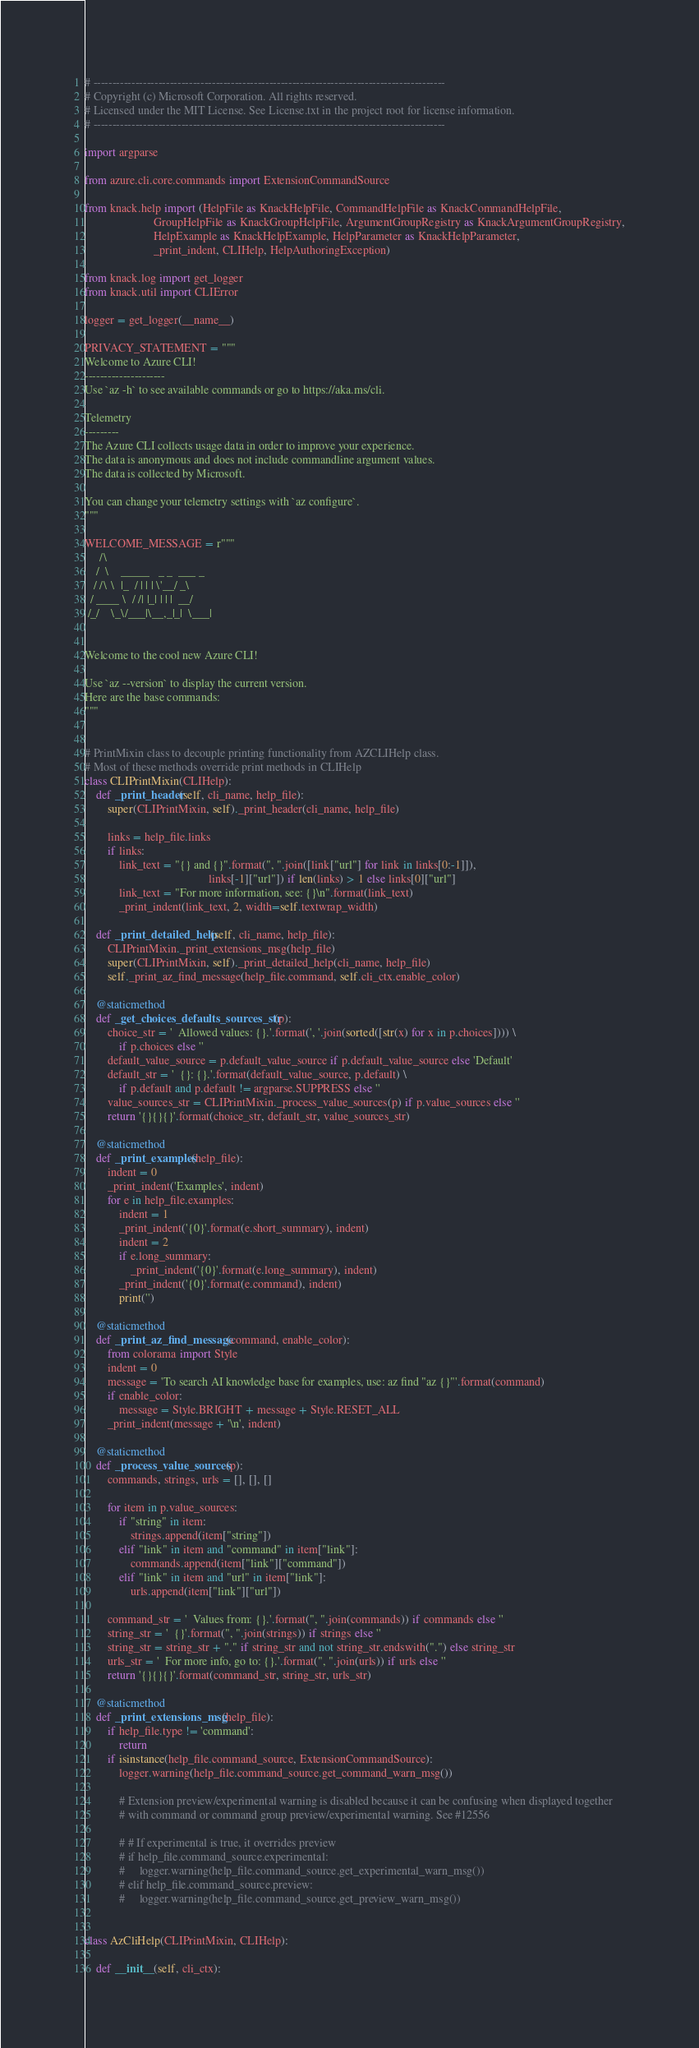<code> <loc_0><loc_0><loc_500><loc_500><_Python_># --------------------------------------------------------------------------------------------
# Copyright (c) Microsoft Corporation. All rights reserved.
# Licensed under the MIT License. See License.txt in the project root for license information.
# --------------------------------------------------------------------------------------------

import argparse

from azure.cli.core.commands import ExtensionCommandSource

from knack.help import (HelpFile as KnackHelpFile, CommandHelpFile as KnackCommandHelpFile,
                        GroupHelpFile as KnackGroupHelpFile, ArgumentGroupRegistry as KnackArgumentGroupRegistry,
                        HelpExample as KnackHelpExample, HelpParameter as KnackHelpParameter,
                        _print_indent, CLIHelp, HelpAuthoringException)

from knack.log import get_logger
from knack.util import CLIError

logger = get_logger(__name__)

PRIVACY_STATEMENT = """
Welcome to Azure CLI!
---------------------
Use `az -h` to see available commands or go to https://aka.ms/cli.

Telemetry
---------
The Azure CLI collects usage data in order to improve your experience.
The data is anonymous and does not include commandline argument values.
The data is collected by Microsoft.

You can change your telemetry settings with `az configure`.
"""

WELCOME_MESSAGE = r"""
     /\
    /  \    _____   _ _  ___ _
   / /\ \  |_  / | | | \'__/ _\
  / ____ \  / /| |_| | | |  __/
 /_/    \_\/___|\__,_|_|  \___|


Welcome to the cool new Azure CLI!

Use `az --version` to display the current version.
Here are the base commands:
"""


# PrintMixin class to decouple printing functionality from AZCLIHelp class.
# Most of these methods override print methods in CLIHelp
class CLIPrintMixin(CLIHelp):
    def _print_header(self, cli_name, help_file):
        super(CLIPrintMixin, self)._print_header(cli_name, help_file)

        links = help_file.links
        if links:
            link_text = "{} and {}".format(", ".join([link["url"] for link in links[0:-1]]),
                                           links[-1]["url"]) if len(links) > 1 else links[0]["url"]
            link_text = "For more information, see: {}\n".format(link_text)
            _print_indent(link_text, 2, width=self.textwrap_width)

    def _print_detailed_help(self, cli_name, help_file):
        CLIPrintMixin._print_extensions_msg(help_file)
        super(CLIPrintMixin, self)._print_detailed_help(cli_name, help_file)
        self._print_az_find_message(help_file.command, self.cli_ctx.enable_color)

    @staticmethod
    def _get_choices_defaults_sources_str(p):
        choice_str = '  Allowed values: {}.'.format(', '.join(sorted([str(x) for x in p.choices]))) \
            if p.choices else ''
        default_value_source = p.default_value_source if p.default_value_source else 'Default'
        default_str = '  {}: {}.'.format(default_value_source, p.default) \
            if p.default and p.default != argparse.SUPPRESS else ''
        value_sources_str = CLIPrintMixin._process_value_sources(p) if p.value_sources else ''
        return '{}{}{}'.format(choice_str, default_str, value_sources_str)

    @staticmethod
    def _print_examples(help_file):
        indent = 0
        _print_indent('Examples', indent)
        for e in help_file.examples:
            indent = 1
            _print_indent('{0}'.format(e.short_summary), indent)
            indent = 2
            if e.long_summary:
                _print_indent('{0}'.format(e.long_summary), indent)
            _print_indent('{0}'.format(e.command), indent)
            print('')

    @staticmethod
    def _print_az_find_message(command, enable_color):
        from colorama import Style
        indent = 0
        message = 'To search AI knowledge base for examples, use: az find "az {}"'.format(command)
        if enable_color:
            message = Style.BRIGHT + message + Style.RESET_ALL
        _print_indent(message + '\n', indent)

    @staticmethod
    def _process_value_sources(p):
        commands, strings, urls = [], [], []

        for item in p.value_sources:
            if "string" in item:
                strings.append(item["string"])
            elif "link" in item and "command" in item["link"]:
                commands.append(item["link"]["command"])
            elif "link" in item and "url" in item["link"]:
                urls.append(item["link"]["url"])

        command_str = '  Values from: {}.'.format(", ".join(commands)) if commands else ''
        string_str = '  {}'.format(", ".join(strings)) if strings else ''
        string_str = string_str + "." if string_str and not string_str.endswith(".") else string_str
        urls_str = '  For more info, go to: {}.'.format(", ".join(urls)) if urls else ''
        return '{}{}{}'.format(command_str, string_str, urls_str)

    @staticmethod
    def _print_extensions_msg(help_file):
        if help_file.type != 'command':
            return
        if isinstance(help_file.command_source, ExtensionCommandSource):
            logger.warning(help_file.command_source.get_command_warn_msg())

            # Extension preview/experimental warning is disabled because it can be confusing when displayed together
            # with command or command group preview/experimental warning. See #12556

            # # If experimental is true, it overrides preview
            # if help_file.command_source.experimental:
            #     logger.warning(help_file.command_source.get_experimental_warn_msg())
            # elif help_file.command_source.preview:
            #     logger.warning(help_file.command_source.get_preview_warn_msg())


class AzCliHelp(CLIPrintMixin, CLIHelp):

    def __init__(self, cli_ctx):</code> 